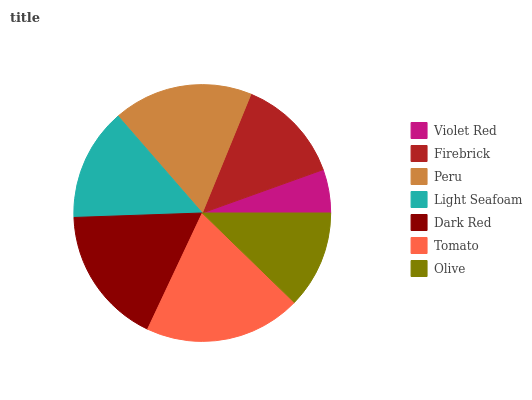Is Violet Red the minimum?
Answer yes or no. Yes. Is Tomato the maximum?
Answer yes or no. Yes. Is Firebrick the minimum?
Answer yes or no. No. Is Firebrick the maximum?
Answer yes or no. No. Is Firebrick greater than Violet Red?
Answer yes or no. Yes. Is Violet Red less than Firebrick?
Answer yes or no. Yes. Is Violet Red greater than Firebrick?
Answer yes or no. No. Is Firebrick less than Violet Red?
Answer yes or no. No. Is Light Seafoam the high median?
Answer yes or no. Yes. Is Light Seafoam the low median?
Answer yes or no. Yes. Is Olive the high median?
Answer yes or no. No. Is Dark Red the low median?
Answer yes or no. No. 